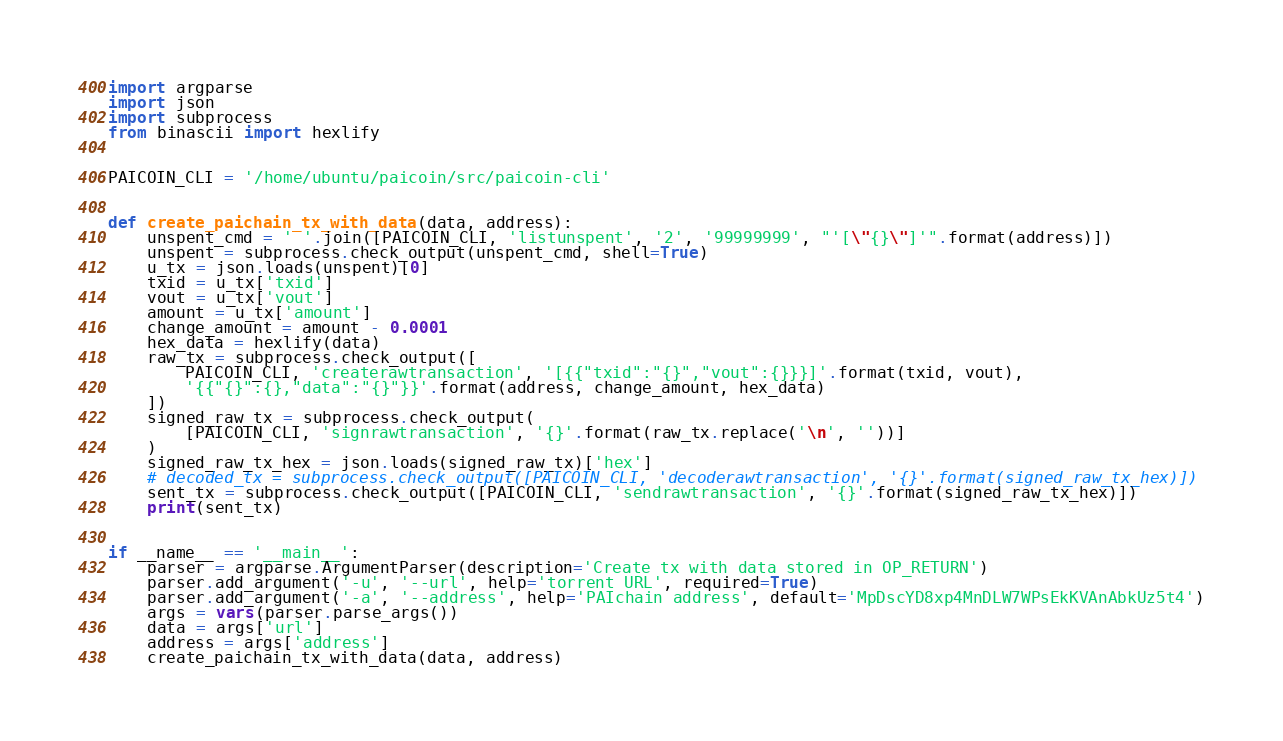Convert code to text. <code><loc_0><loc_0><loc_500><loc_500><_Python_>import argparse
import json
import subprocess
from binascii import hexlify


PAICOIN_CLI = '/home/ubuntu/paicoin/src/paicoin-cli'


def create_paichain_tx_with_data(data, address):
    unspent_cmd = ' '.join([PAICOIN_CLI, 'listunspent', '2', '99999999', "'[\"{}\"]'".format(address)])
    unspent = subprocess.check_output(unspent_cmd, shell=True)
    u_tx = json.loads(unspent)[0]
    txid = u_tx['txid']
    vout = u_tx['vout']
    amount = u_tx['amount']
    change_amount = amount - 0.0001
    hex_data = hexlify(data)
    raw_tx = subprocess.check_output([
        PAICOIN_CLI, 'createrawtransaction', '[{{"txid":"{}","vout":{}}}]'.format(txid, vout),
        '{{"{}":{},"data":"{}"}}'.format(address, change_amount, hex_data)
    ])
    signed_raw_tx = subprocess.check_output(
        [PAICOIN_CLI, 'signrawtransaction', '{}'.format(raw_tx.replace('\n', ''))]
    )
    signed_raw_tx_hex = json.loads(signed_raw_tx)['hex']
    # decoded_tx = subprocess.check_output([PAICOIN_CLI, 'decoderawtransaction', '{}'.format(signed_raw_tx_hex)])
    sent_tx = subprocess.check_output([PAICOIN_CLI, 'sendrawtransaction', '{}'.format(signed_raw_tx_hex)])
    print(sent_tx)


if __name__ == '__main__':
    parser = argparse.ArgumentParser(description='Create tx with data stored in OP_RETURN')
    parser.add_argument('-u', '--url', help='torrent URL', required=True)
    parser.add_argument('-a', '--address', help='PAIchain address', default='MpDscYD8xp4MnDLW7WPsEkKVAnAbkUz5t4')
    args = vars(parser.parse_args())
    data = args['url']
    address = args['address']
    create_paichain_tx_with_data(data, address)
</code> 